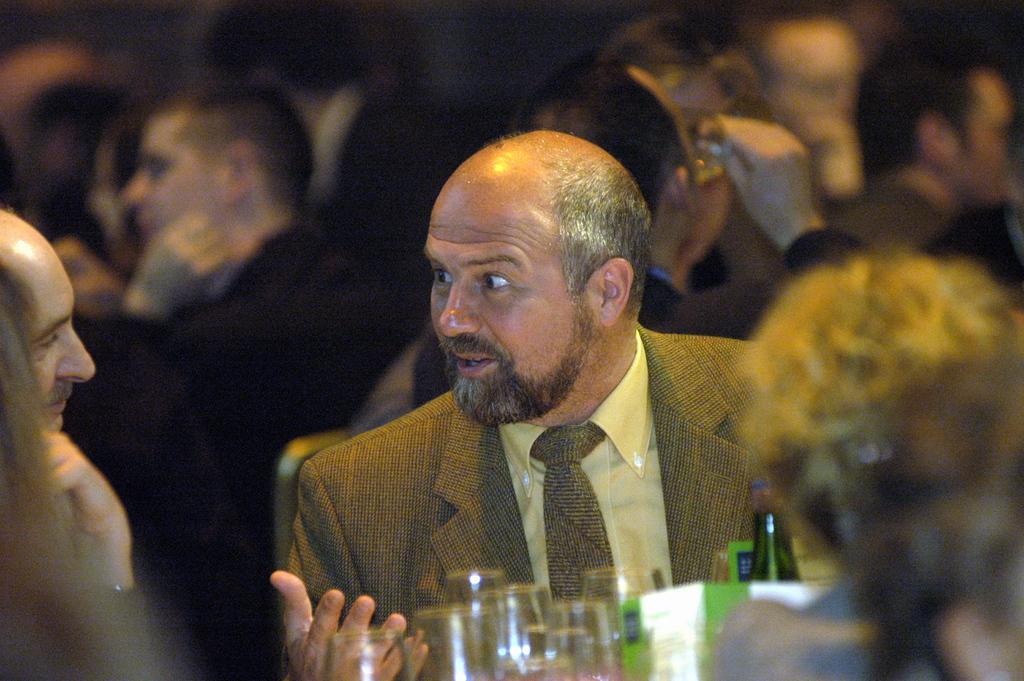In one or two sentences, can you explain what this image depicts? In this image I can see some people. I can see some glasses. 